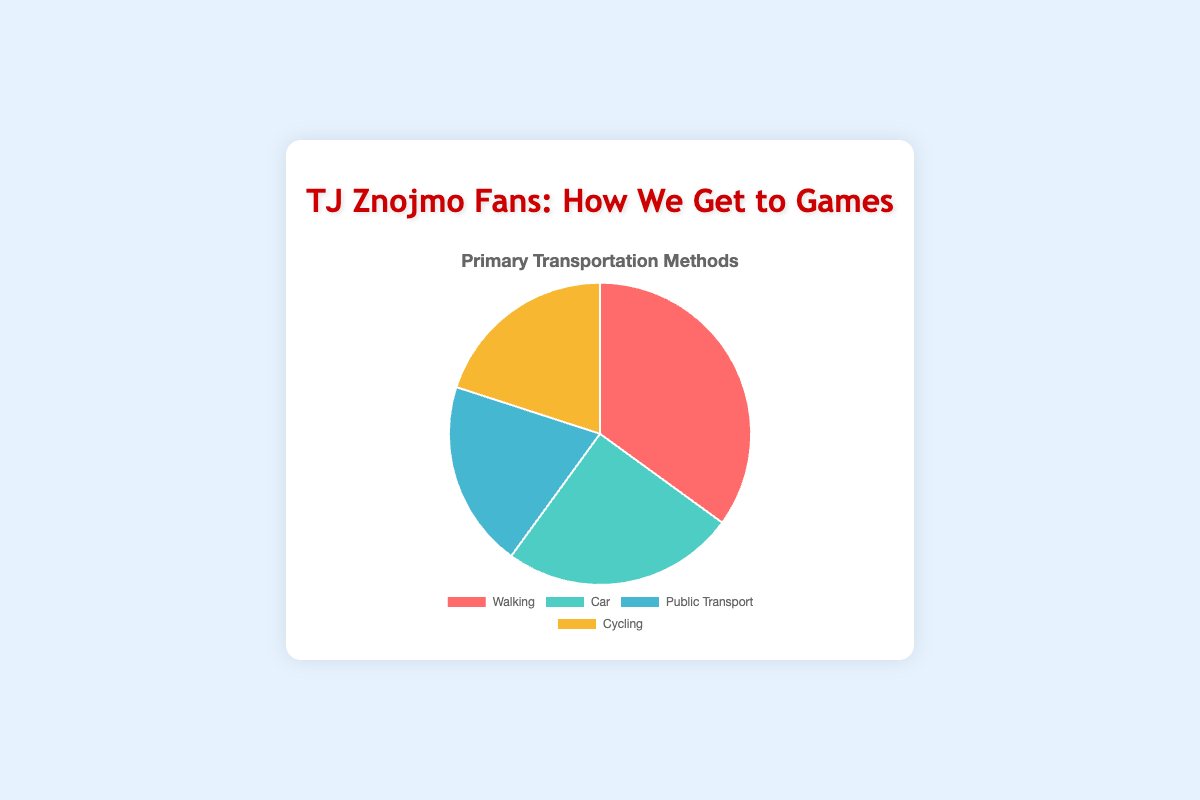What transportation method do most TJ Znojmo fans use to get to games? The pie chart shows that 35% use walking, which is the highest percentage among all methods.
Answer: Walking Which two transportation methods are equally popular among TJ Znojmo fans? The pie chart shows that both public transport and cycling have a 20% share each.
Answer: Public Transport and Cycling What is the combined percentage of fans using either public transport or cycling to get to games? The percentages are 20% for public transport and 20% for cycling. Adding them together results in 40%.
Answer: 40% What is the difference in percentage between the most popular and the least popular transportation method? The most popular method is walking at 35%, and the least popular methods are public transport and cycling at 20%. The difference is 35% - 20% = 15%.
Answer: 15% What percentage of fans use a car to get to games compared to those who walk? The pie chart shows that 25% use a car, whereas 35% walk.
Answer: 25% compared to 35% What is the most common color used in the pie chart and which transportation method does it represent? The most common color is red, which represents walking.
Answer: Red, Walking How much more likely are fans to walk to games than to use public transport? Walking is 35% whereas public transport is 20%. The difference is 35% - 20% = 15%.
Answer: 15% more likely If you were to combine the percentages of fans using cars and those cycling, would their combined total surpass those who walk? Cars are at 25% and cycling is at 20%. Combined, they total 45%, which surpasses 35% for walking.
Answer: Yes, 45% What is the total percentage of fans who do not use walking as their primary transportation method? The sum of fans using car (25%), public transport (20%), and cycling (20%) is 25% + 20% + 20% = 65%.
Answer: 65% If TJ Znojmo fans' transportation methods were segmented into those who use non-motorized methods versus motorized methods, what would the respective percentages be? Non-motorized methods (walking and cycling) add up to 35% + 20% = 55%, while motorized methods (car and public transport) sum up to 25% + 20% = 45%.
Answer: Non-motorized: 55%, Motorized: 45% 